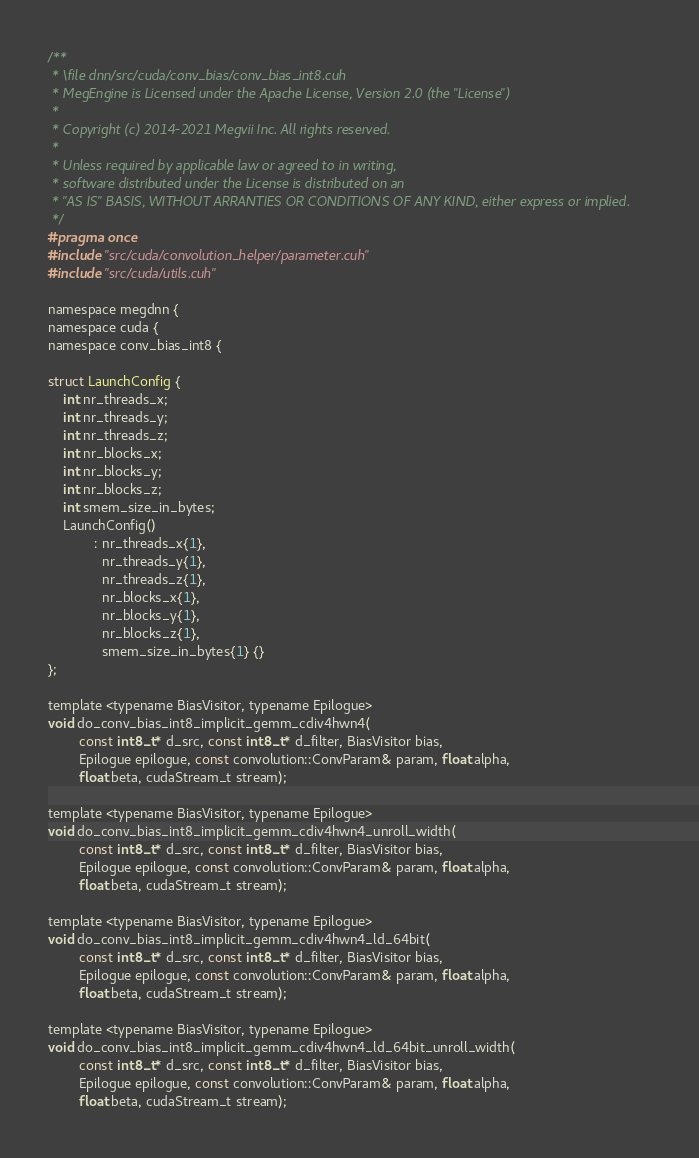Convert code to text. <code><loc_0><loc_0><loc_500><loc_500><_Cuda_>/**
 * \file dnn/src/cuda/conv_bias/conv_bias_int8.cuh
 * MegEngine is Licensed under the Apache License, Version 2.0 (the "License")
 *
 * Copyright (c) 2014-2021 Megvii Inc. All rights reserved.
 *
 * Unless required by applicable law or agreed to in writing,
 * software distributed under the License is distributed on an
 * "AS IS" BASIS, WITHOUT ARRANTIES OR CONDITIONS OF ANY KIND, either express or implied.
 */
#pragma once
#include "src/cuda/convolution_helper/parameter.cuh"
#include "src/cuda/utils.cuh"

namespace megdnn {
namespace cuda {
namespace conv_bias_int8 {

struct LaunchConfig {
    int nr_threads_x;
    int nr_threads_y;
    int nr_threads_z;
    int nr_blocks_x;
    int nr_blocks_y;
    int nr_blocks_z;
    int smem_size_in_bytes;
    LaunchConfig()
            : nr_threads_x{1},
              nr_threads_y{1},
              nr_threads_z{1},
              nr_blocks_x{1},
              nr_blocks_y{1},
              nr_blocks_z{1},
              smem_size_in_bytes{1} {}
};

template <typename BiasVisitor, typename Epilogue>
void do_conv_bias_int8_implicit_gemm_cdiv4hwn4(
        const int8_t* d_src, const int8_t* d_filter, BiasVisitor bias,
        Epilogue epilogue, const convolution::ConvParam& param, float alpha,
        float beta, cudaStream_t stream);

template <typename BiasVisitor, typename Epilogue>
void do_conv_bias_int8_implicit_gemm_cdiv4hwn4_unroll_width(
        const int8_t* d_src, const int8_t* d_filter, BiasVisitor bias,
        Epilogue epilogue, const convolution::ConvParam& param, float alpha,
        float beta, cudaStream_t stream);

template <typename BiasVisitor, typename Epilogue>
void do_conv_bias_int8_implicit_gemm_cdiv4hwn4_ld_64bit(
        const int8_t* d_src, const int8_t* d_filter, BiasVisitor bias,
        Epilogue epilogue, const convolution::ConvParam& param, float alpha,
        float beta, cudaStream_t stream);

template <typename BiasVisitor, typename Epilogue>
void do_conv_bias_int8_implicit_gemm_cdiv4hwn4_ld_64bit_unroll_width(
        const int8_t* d_src, const int8_t* d_filter, BiasVisitor bias,
        Epilogue epilogue, const convolution::ConvParam& param, float alpha,
        float beta, cudaStream_t stream);
</code> 